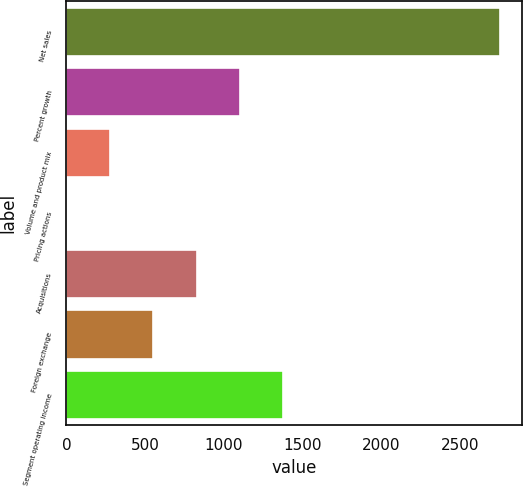<chart> <loc_0><loc_0><loc_500><loc_500><bar_chart><fcel>Net sales<fcel>Percent growth<fcel>Volume and product mix<fcel>Pricing actions<fcel>Acquisitions<fcel>Foreign exchange<fcel>Segment operating income<nl><fcel>2753.2<fcel>1102<fcel>276.4<fcel>1.2<fcel>826.8<fcel>551.6<fcel>1377.2<nl></chart> 